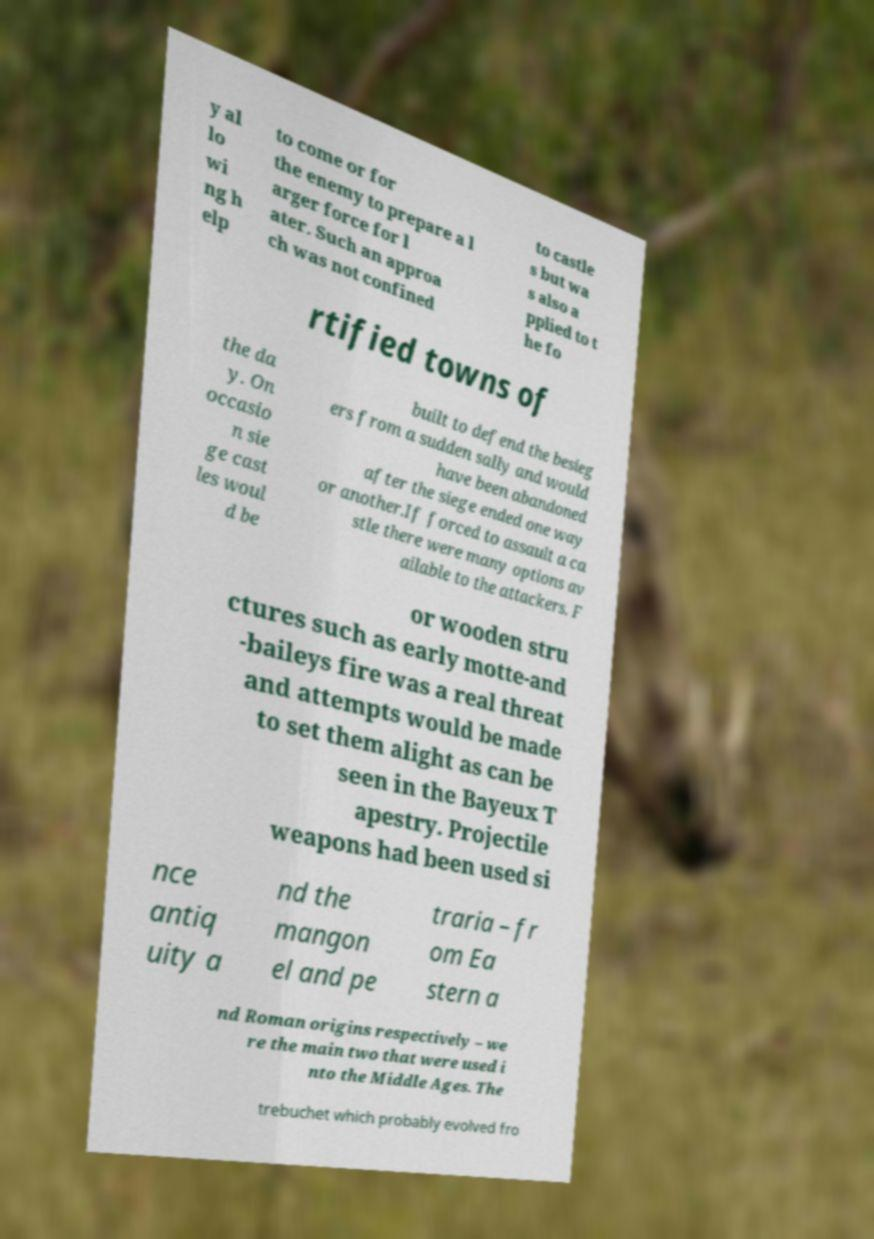Can you read and provide the text displayed in the image?This photo seems to have some interesting text. Can you extract and type it out for me? y al lo wi ng h elp to come or for the enemy to prepare a l arger force for l ater. Such an approa ch was not confined to castle s but wa s also a pplied to t he fo rtified towns of the da y. On occasio n sie ge cast les woul d be built to defend the besieg ers from a sudden sally and would have been abandoned after the siege ended one way or another.If forced to assault a ca stle there were many options av ailable to the attackers. F or wooden stru ctures such as early motte-and -baileys fire was a real threat and attempts would be made to set them alight as can be seen in the Bayeux T apestry. Projectile weapons had been used si nce antiq uity a nd the mangon el and pe traria – fr om Ea stern a nd Roman origins respectively – we re the main two that were used i nto the Middle Ages. The trebuchet which probably evolved fro 